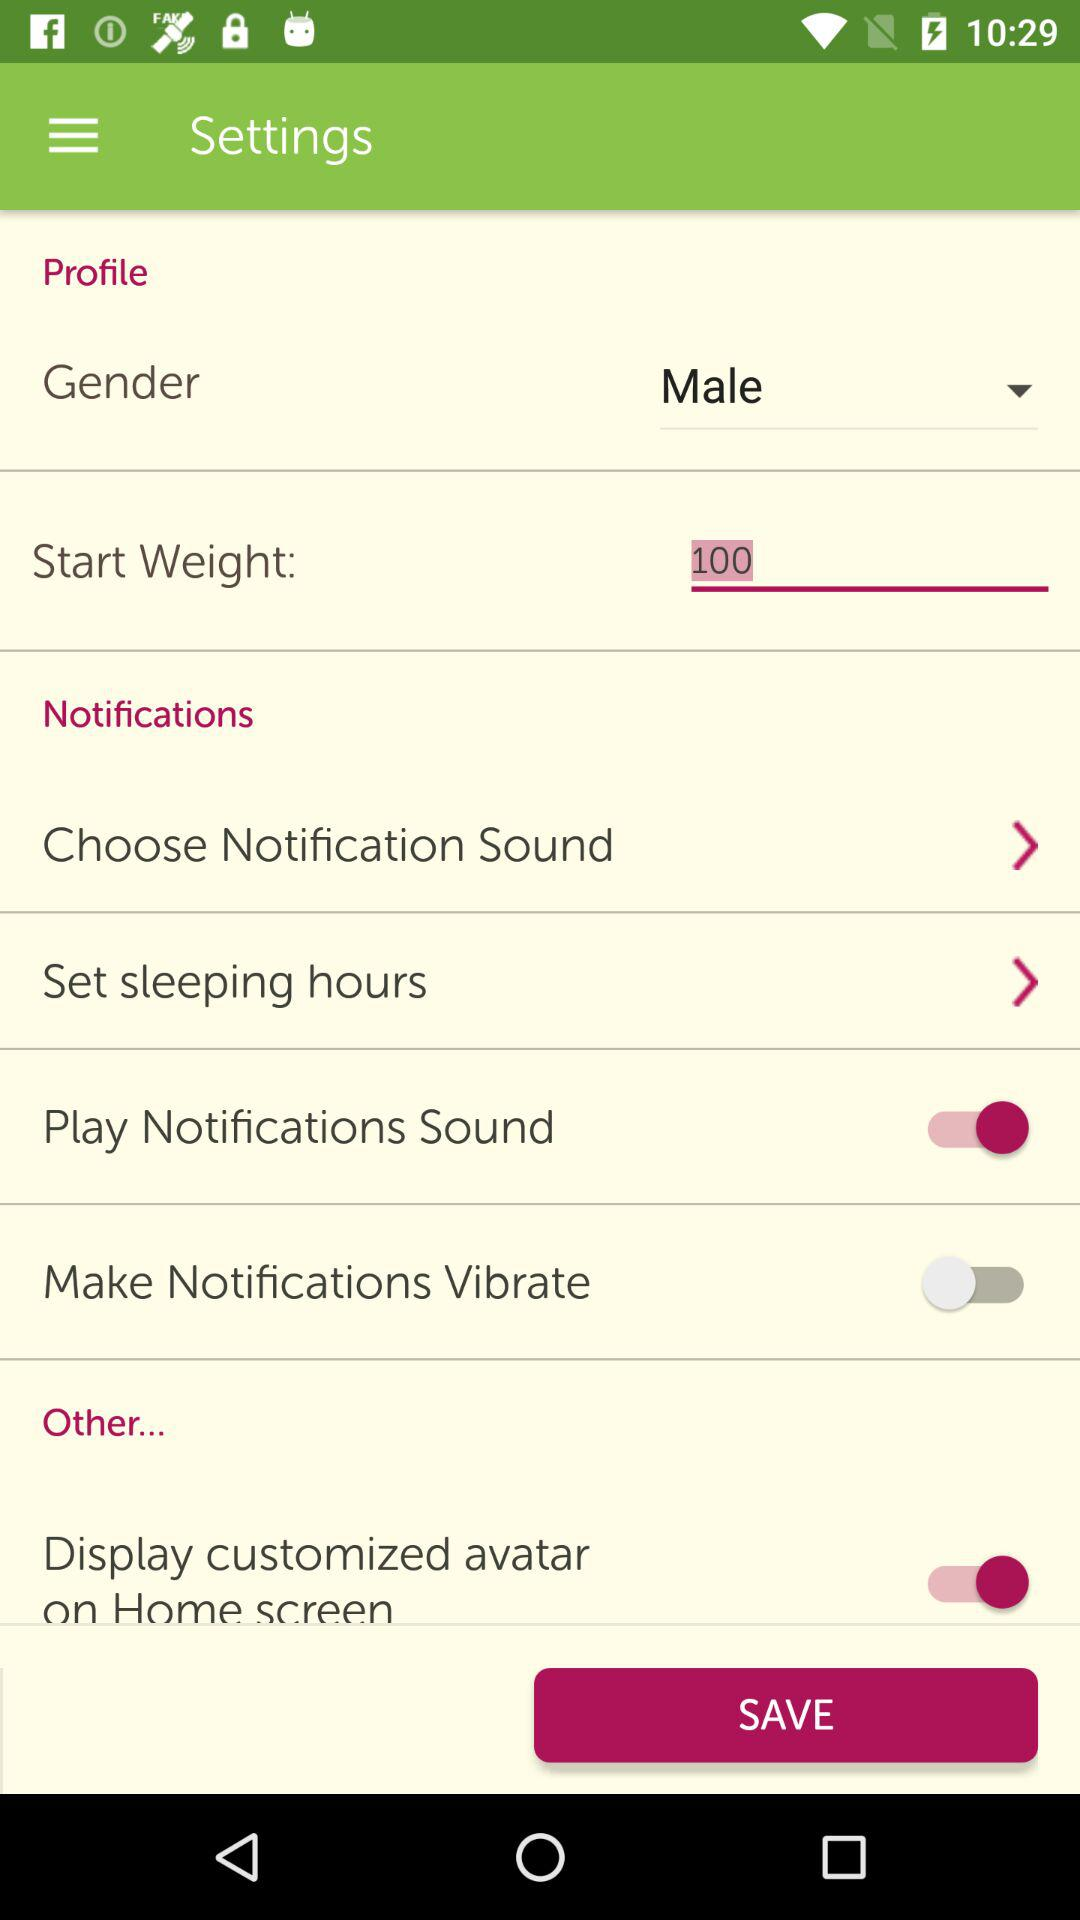What is the status of the "Make Notifications Vibrate"? The status is "off". 